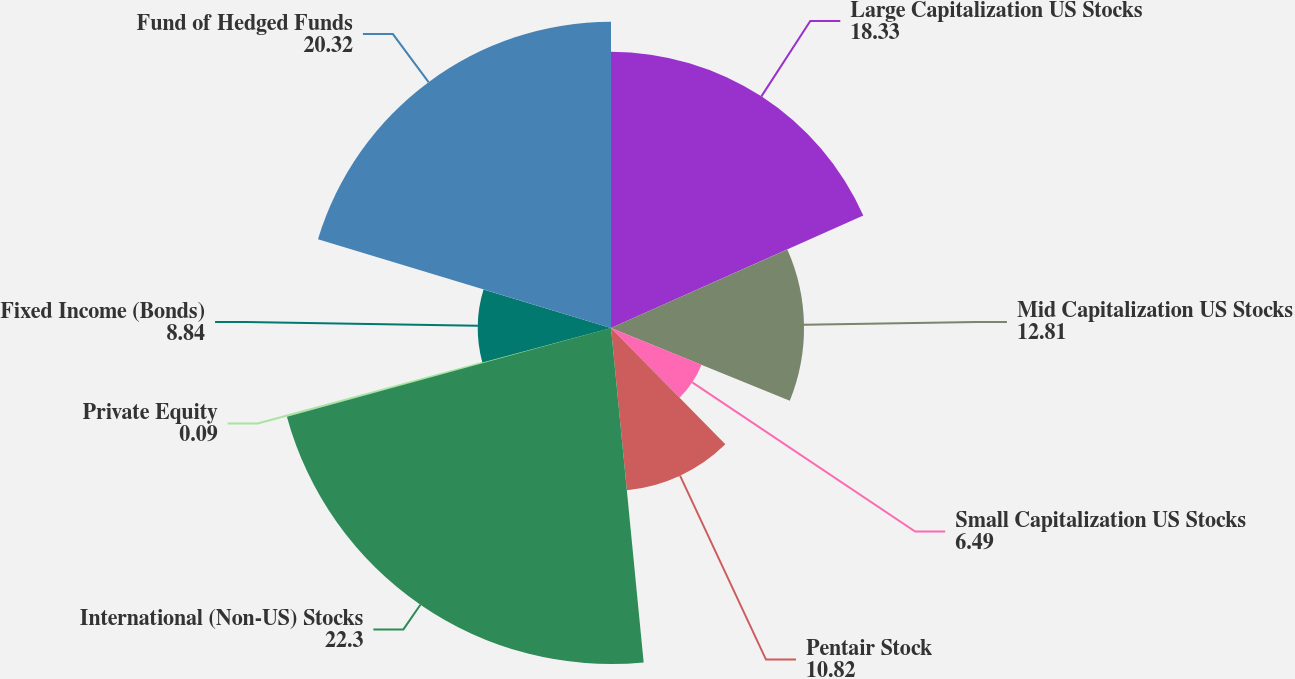Convert chart. <chart><loc_0><loc_0><loc_500><loc_500><pie_chart><fcel>Large Capitalization US Stocks<fcel>Mid Capitalization US Stocks<fcel>Small Capitalization US Stocks<fcel>Pentair Stock<fcel>International (Non-US) Stocks<fcel>Private Equity<fcel>Fixed Income (Bonds)<fcel>Fund of Hedged Funds<nl><fcel>18.33%<fcel>12.81%<fcel>6.49%<fcel>10.82%<fcel>22.3%<fcel>0.09%<fcel>8.84%<fcel>20.32%<nl></chart> 